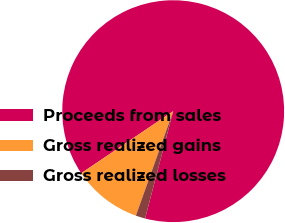Convert chart to OTSL. <chart><loc_0><loc_0><loc_500><loc_500><pie_chart><fcel>Proceeds from sales<fcel>Gross realized gains<fcel>Gross realized losses<nl><fcel>88.52%<fcel>10.1%<fcel>1.38%<nl></chart> 